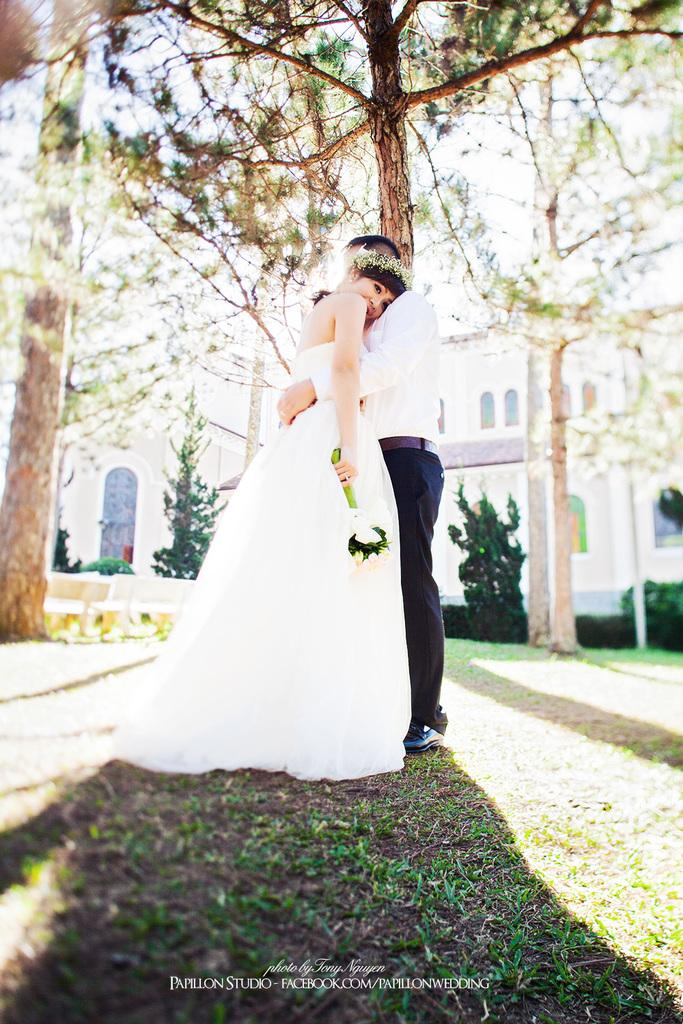What is happening between the man and the woman in the image? The man is hugging a woman in the image. What is the woman wearing? The woman is wearing a white dress. What is the woman holding in the image? The woman is holding a bouquet. What can be seen in the background of the image? There is a building, plants, and trees in the background of the image. What is present at the bottom of the image? There is a watermark at the bottom of the image. What type of religious ceremony is taking place in the image? There is no indication of a religious ceremony in the image; it simply shows a man hugging a woman. What type of cabbage can be seen growing in the background of the image? There are no cabbages present in the image; only plants and trees can be seen in the background. 